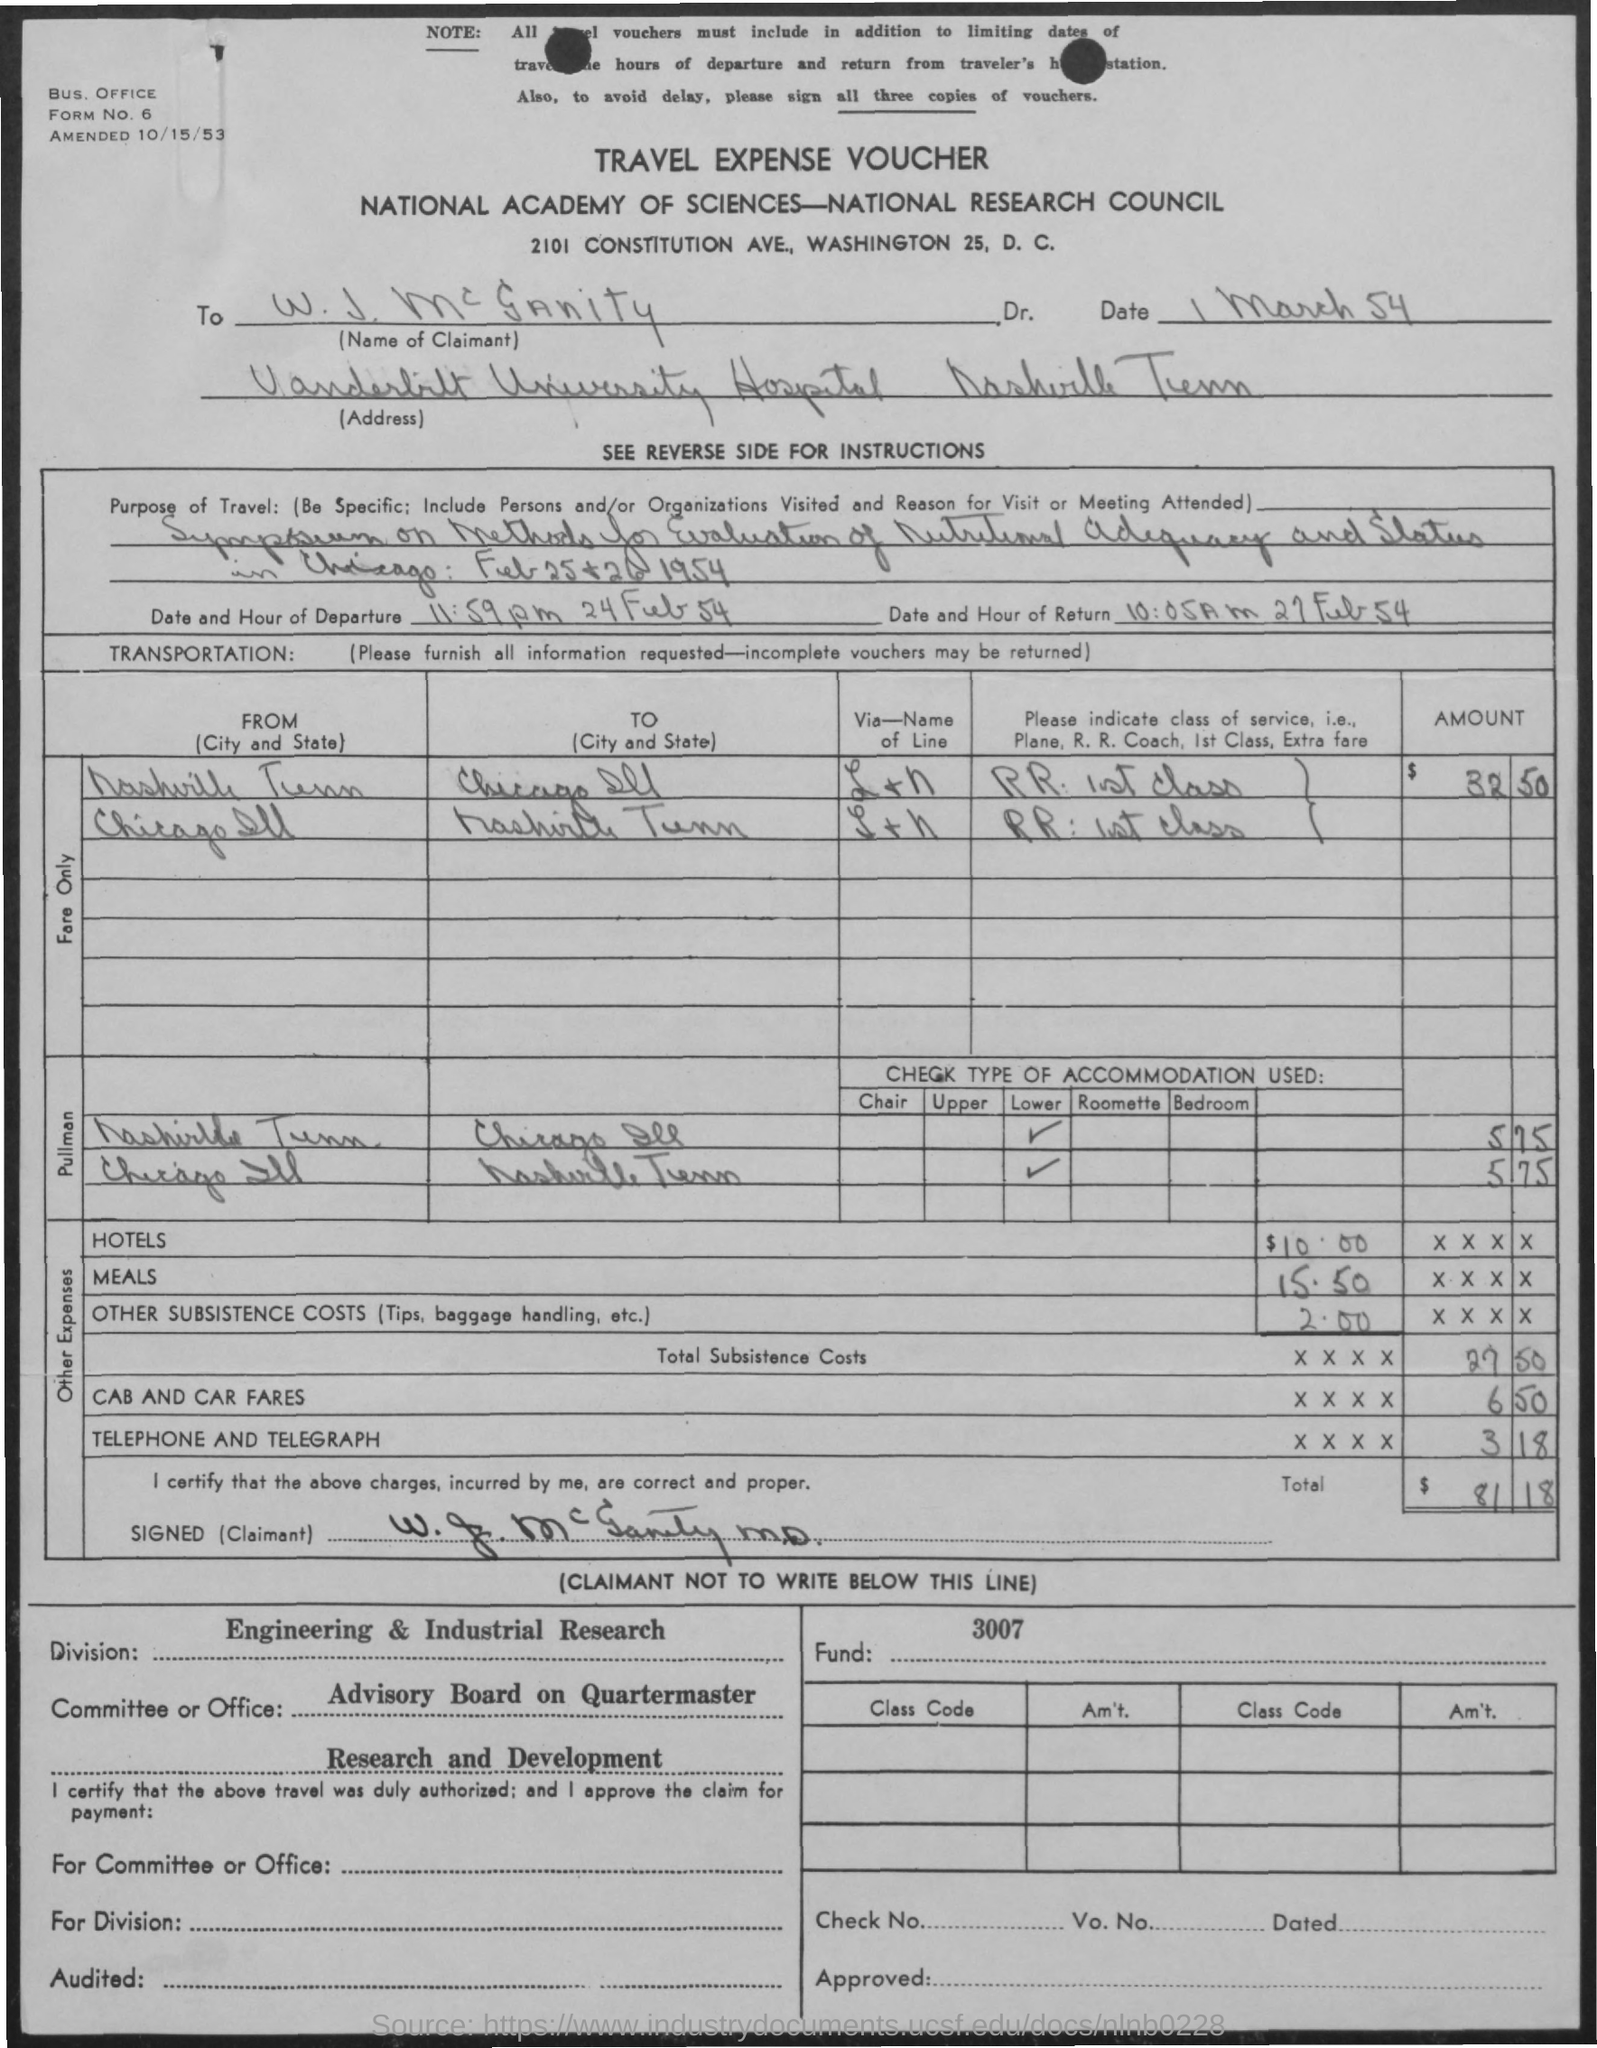How much were the total expenses for the trip? The total expenses for the trip amounted to $111.12, which includes transportation, hotel, meals, subsistence costs, cab, and car fares, as well as telephone and telegraph charges. 